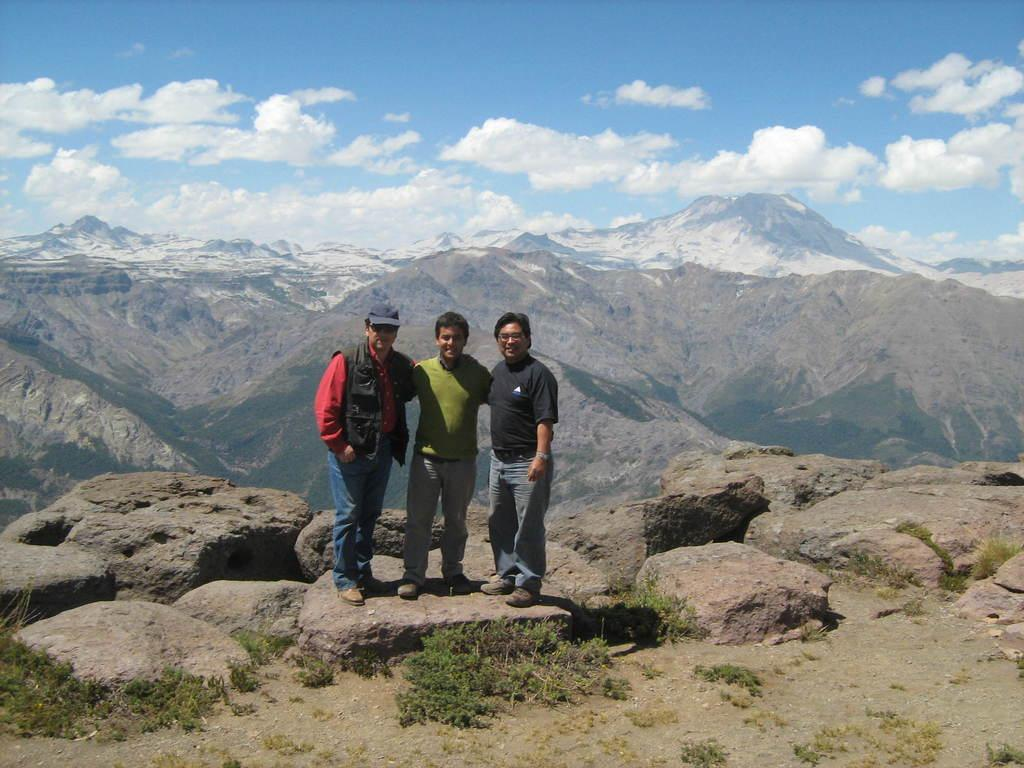How many men are in the image? There are three men in the image. Where are the men standing? The men are standing on a rock. What else can be seen in the image besides the men? There are plants in the image. What is visible in the background of the image? There are mountains and the sky in the background of the image. What can be observed in the sky? Clouds are present in the sky. What type of straw is being used by the men in the image? There is no straw present in the image. Can you see any cheese in the image? There is no cheese present in the image. 